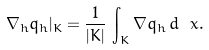<formula> <loc_0><loc_0><loc_500><loc_500>\nabla _ { h } q _ { h } | _ { K } = \frac { 1 } { | K | } \, \int _ { K } \nabla q _ { h } \, d \ x .</formula> 